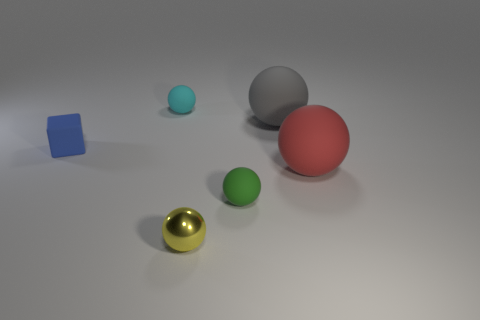How many things are either small matte objects behind the small blue thing or cyan balls behind the blue block? There are a total of two objects that meet the criteria of being either small matte objects behind the small blue thing or cyan balls behind the blue block. Specifically, there is one small matte object – a gray ball – behind the small blue cube, and one cyan ball behind the blue cube. 